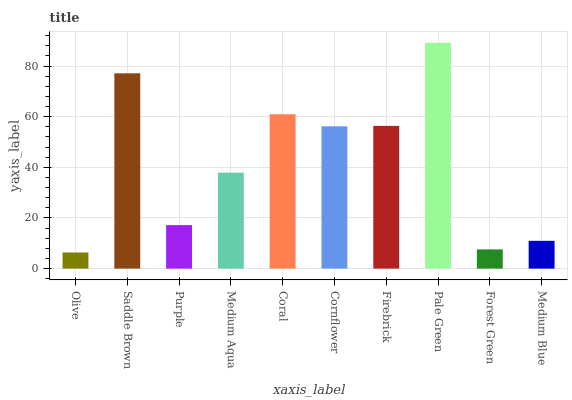Is Olive the minimum?
Answer yes or no. Yes. Is Pale Green the maximum?
Answer yes or no. Yes. Is Saddle Brown the minimum?
Answer yes or no. No. Is Saddle Brown the maximum?
Answer yes or no. No. Is Saddle Brown greater than Olive?
Answer yes or no. Yes. Is Olive less than Saddle Brown?
Answer yes or no. Yes. Is Olive greater than Saddle Brown?
Answer yes or no. No. Is Saddle Brown less than Olive?
Answer yes or no. No. Is Cornflower the high median?
Answer yes or no. Yes. Is Medium Aqua the low median?
Answer yes or no. Yes. Is Pale Green the high median?
Answer yes or no. No. Is Saddle Brown the low median?
Answer yes or no. No. 